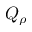<formula> <loc_0><loc_0><loc_500><loc_500>Q _ { \rho }</formula> 